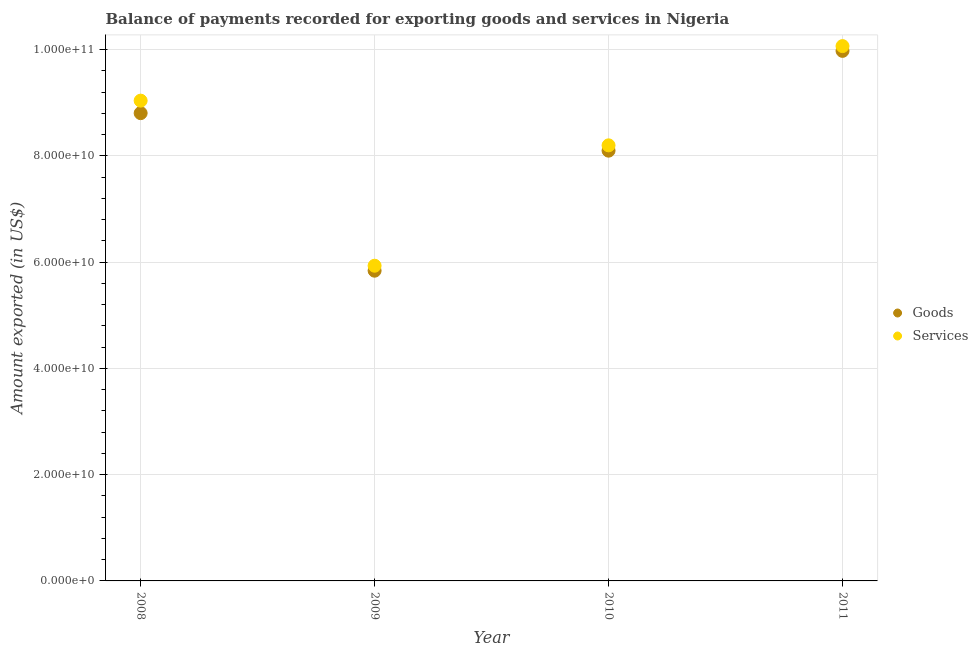Is the number of dotlines equal to the number of legend labels?
Your answer should be very brief. Yes. What is the amount of goods exported in 2010?
Keep it short and to the point. 8.10e+1. Across all years, what is the maximum amount of goods exported?
Ensure brevity in your answer.  9.98e+1. Across all years, what is the minimum amount of goods exported?
Provide a succinct answer. 5.84e+1. In which year was the amount of services exported maximum?
Provide a succinct answer. 2011. In which year was the amount of goods exported minimum?
Offer a very short reply. 2009. What is the total amount of goods exported in the graph?
Give a very brief answer. 3.27e+11. What is the difference between the amount of services exported in 2009 and that in 2010?
Your answer should be compact. -2.27e+1. What is the difference between the amount of goods exported in 2011 and the amount of services exported in 2010?
Make the answer very short. 1.78e+1. What is the average amount of services exported per year?
Make the answer very short. 8.31e+1. In the year 2011, what is the difference between the amount of goods exported and amount of services exported?
Ensure brevity in your answer.  -8.98e+08. What is the ratio of the amount of services exported in 2010 to that in 2011?
Offer a very short reply. 0.81. What is the difference between the highest and the second highest amount of goods exported?
Provide a short and direct response. 1.17e+1. What is the difference between the highest and the lowest amount of services exported?
Make the answer very short. 4.13e+1. In how many years, is the amount of services exported greater than the average amount of services exported taken over all years?
Give a very brief answer. 2. Is the sum of the amount of services exported in 2009 and 2011 greater than the maximum amount of goods exported across all years?
Provide a short and direct response. Yes. Is the amount of services exported strictly less than the amount of goods exported over the years?
Your response must be concise. No. What is the difference between two consecutive major ticks on the Y-axis?
Your answer should be compact. 2.00e+1. Does the graph contain grids?
Keep it short and to the point. Yes. Where does the legend appear in the graph?
Provide a succinct answer. Center right. How many legend labels are there?
Your answer should be compact. 2. How are the legend labels stacked?
Provide a short and direct response. Vertical. What is the title of the graph?
Provide a short and direct response. Balance of payments recorded for exporting goods and services in Nigeria. What is the label or title of the Y-axis?
Provide a short and direct response. Amount exported (in US$). What is the Amount exported (in US$) of Goods in 2008?
Offer a terse response. 8.80e+1. What is the Amount exported (in US$) of Services in 2008?
Your answer should be very brief. 9.04e+1. What is the Amount exported (in US$) in Goods in 2009?
Offer a terse response. 5.84e+1. What is the Amount exported (in US$) in Services in 2009?
Ensure brevity in your answer.  5.93e+1. What is the Amount exported (in US$) of Goods in 2010?
Your answer should be compact. 8.10e+1. What is the Amount exported (in US$) of Services in 2010?
Provide a short and direct response. 8.20e+1. What is the Amount exported (in US$) in Goods in 2011?
Provide a short and direct response. 9.98e+1. What is the Amount exported (in US$) of Services in 2011?
Give a very brief answer. 1.01e+11. Across all years, what is the maximum Amount exported (in US$) in Goods?
Offer a very short reply. 9.98e+1. Across all years, what is the maximum Amount exported (in US$) in Services?
Ensure brevity in your answer.  1.01e+11. Across all years, what is the minimum Amount exported (in US$) in Goods?
Provide a succinct answer. 5.84e+1. Across all years, what is the minimum Amount exported (in US$) of Services?
Offer a very short reply. 5.93e+1. What is the total Amount exported (in US$) in Goods in the graph?
Ensure brevity in your answer.  3.27e+11. What is the total Amount exported (in US$) of Services in the graph?
Offer a terse response. 3.32e+11. What is the difference between the Amount exported (in US$) in Goods in 2008 and that in 2009?
Give a very brief answer. 2.97e+1. What is the difference between the Amount exported (in US$) of Services in 2008 and that in 2009?
Your answer should be very brief. 3.11e+1. What is the difference between the Amount exported (in US$) in Goods in 2008 and that in 2010?
Ensure brevity in your answer.  7.06e+09. What is the difference between the Amount exported (in US$) of Services in 2008 and that in 2010?
Ensure brevity in your answer.  8.41e+09. What is the difference between the Amount exported (in US$) in Goods in 2008 and that in 2011?
Offer a very short reply. -1.17e+1. What is the difference between the Amount exported (in US$) in Services in 2008 and that in 2011?
Keep it short and to the point. -1.03e+1. What is the difference between the Amount exported (in US$) of Goods in 2009 and that in 2010?
Your response must be concise. -2.26e+1. What is the difference between the Amount exported (in US$) in Services in 2009 and that in 2010?
Offer a very short reply. -2.27e+1. What is the difference between the Amount exported (in US$) in Goods in 2009 and that in 2011?
Ensure brevity in your answer.  -4.14e+1. What is the difference between the Amount exported (in US$) in Services in 2009 and that in 2011?
Offer a terse response. -4.13e+1. What is the difference between the Amount exported (in US$) in Goods in 2010 and that in 2011?
Make the answer very short. -1.88e+1. What is the difference between the Amount exported (in US$) of Services in 2010 and that in 2011?
Your response must be concise. -1.87e+1. What is the difference between the Amount exported (in US$) in Goods in 2008 and the Amount exported (in US$) in Services in 2009?
Make the answer very short. 2.87e+1. What is the difference between the Amount exported (in US$) in Goods in 2008 and the Amount exported (in US$) in Services in 2010?
Your response must be concise. 6.06e+09. What is the difference between the Amount exported (in US$) in Goods in 2008 and the Amount exported (in US$) in Services in 2011?
Offer a terse response. -1.26e+1. What is the difference between the Amount exported (in US$) of Goods in 2009 and the Amount exported (in US$) of Services in 2010?
Ensure brevity in your answer.  -2.36e+1. What is the difference between the Amount exported (in US$) in Goods in 2009 and the Amount exported (in US$) in Services in 2011?
Offer a terse response. -4.23e+1. What is the difference between the Amount exported (in US$) in Goods in 2010 and the Amount exported (in US$) in Services in 2011?
Your answer should be very brief. -1.97e+1. What is the average Amount exported (in US$) of Goods per year?
Give a very brief answer. 8.18e+1. What is the average Amount exported (in US$) of Services per year?
Offer a terse response. 8.31e+1. In the year 2008, what is the difference between the Amount exported (in US$) of Goods and Amount exported (in US$) of Services?
Provide a short and direct response. -2.35e+09. In the year 2009, what is the difference between the Amount exported (in US$) of Goods and Amount exported (in US$) of Services?
Give a very brief answer. -9.35e+08. In the year 2010, what is the difference between the Amount exported (in US$) in Goods and Amount exported (in US$) in Services?
Offer a terse response. -1.00e+09. In the year 2011, what is the difference between the Amount exported (in US$) of Goods and Amount exported (in US$) of Services?
Make the answer very short. -8.98e+08. What is the ratio of the Amount exported (in US$) in Goods in 2008 to that in 2009?
Offer a terse response. 1.51. What is the ratio of the Amount exported (in US$) in Services in 2008 to that in 2009?
Provide a succinct answer. 1.52. What is the ratio of the Amount exported (in US$) in Goods in 2008 to that in 2010?
Offer a terse response. 1.09. What is the ratio of the Amount exported (in US$) in Services in 2008 to that in 2010?
Offer a very short reply. 1.1. What is the ratio of the Amount exported (in US$) in Goods in 2008 to that in 2011?
Keep it short and to the point. 0.88. What is the ratio of the Amount exported (in US$) in Services in 2008 to that in 2011?
Offer a very short reply. 0.9. What is the ratio of the Amount exported (in US$) of Goods in 2009 to that in 2010?
Offer a very short reply. 0.72. What is the ratio of the Amount exported (in US$) of Services in 2009 to that in 2010?
Give a very brief answer. 0.72. What is the ratio of the Amount exported (in US$) in Goods in 2009 to that in 2011?
Your response must be concise. 0.59. What is the ratio of the Amount exported (in US$) of Services in 2009 to that in 2011?
Provide a short and direct response. 0.59. What is the ratio of the Amount exported (in US$) in Goods in 2010 to that in 2011?
Provide a short and direct response. 0.81. What is the ratio of the Amount exported (in US$) in Services in 2010 to that in 2011?
Offer a very short reply. 0.81. What is the difference between the highest and the second highest Amount exported (in US$) of Goods?
Your answer should be very brief. 1.17e+1. What is the difference between the highest and the second highest Amount exported (in US$) of Services?
Ensure brevity in your answer.  1.03e+1. What is the difference between the highest and the lowest Amount exported (in US$) in Goods?
Your answer should be compact. 4.14e+1. What is the difference between the highest and the lowest Amount exported (in US$) in Services?
Offer a very short reply. 4.13e+1. 